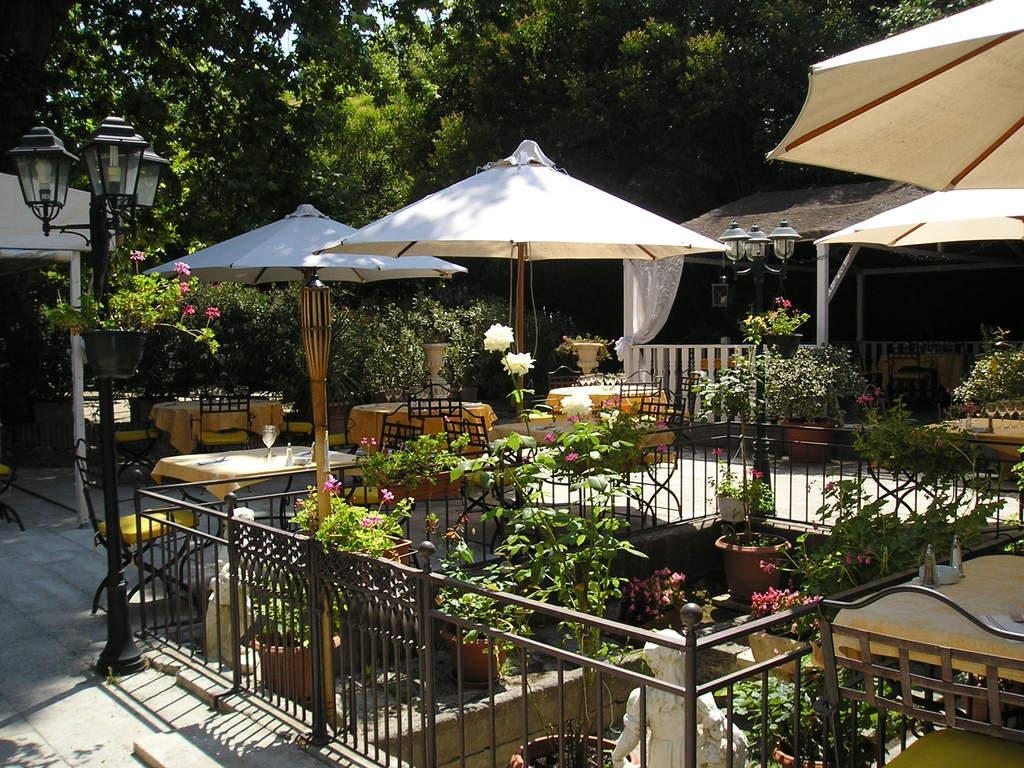Describe this image in one or two sentences. In the center of the image we can see the poles, plants, fences, tables, chairs, outdoor umbrellas, one shed, one tent, sculptures, plant pots, flowers, which are in different colors and a few other objects. On the table, we can see tablecloths, glasses and a few other objects. In the background we can see the sky, trees, one curtain etc. 